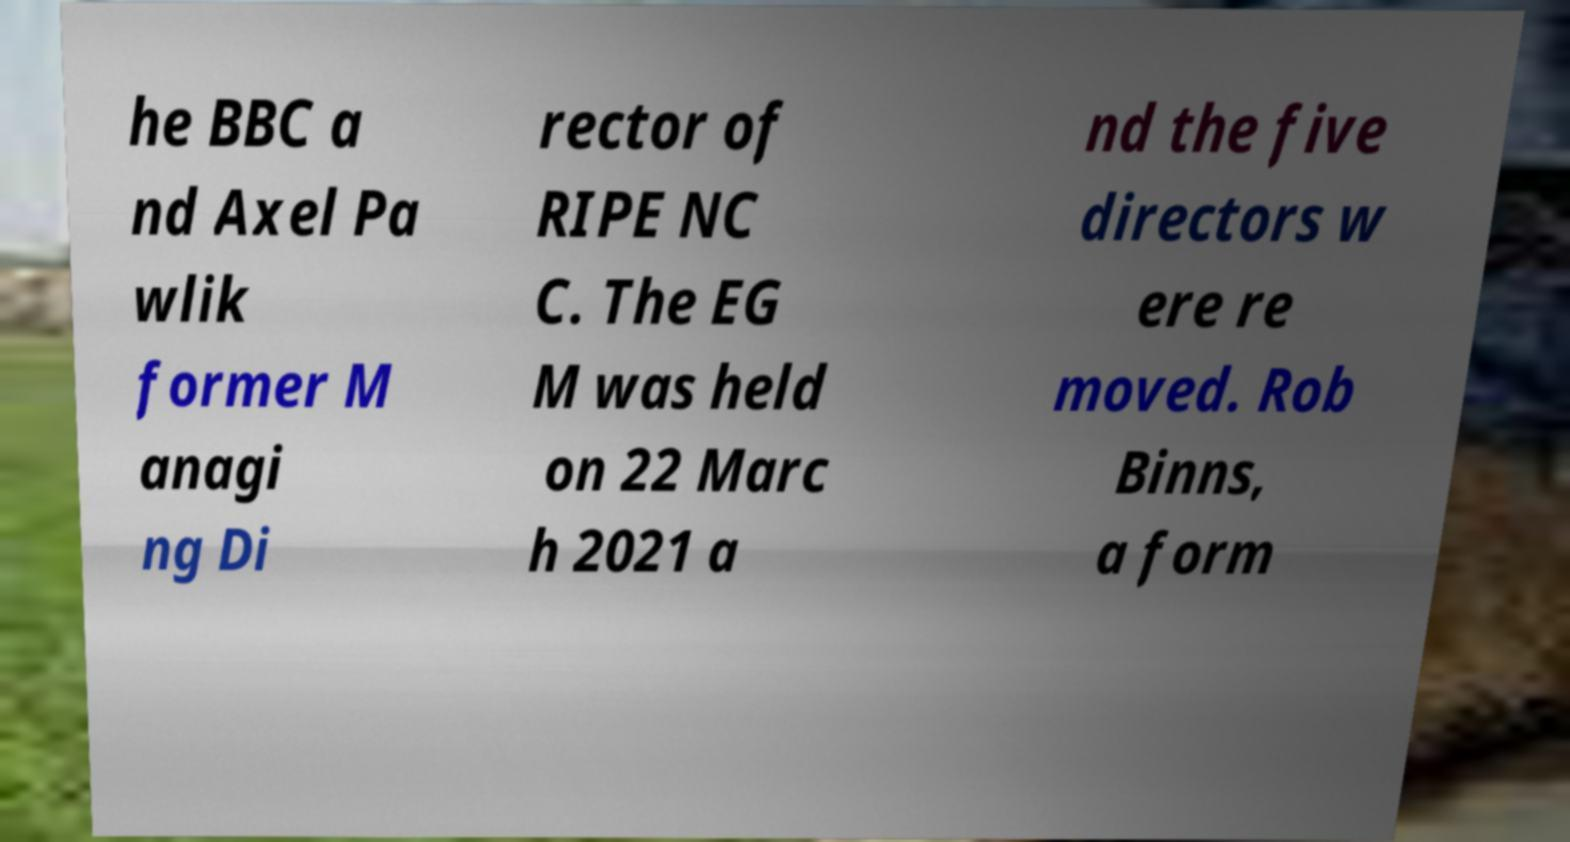Can you accurately transcribe the text from the provided image for me? he BBC a nd Axel Pa wlik former M anagi ng Di rector of RIPE NC C. The EG M was held on 22 Marc h 2021 a nd the five directors w ere re moved. Rob Binns, a form 